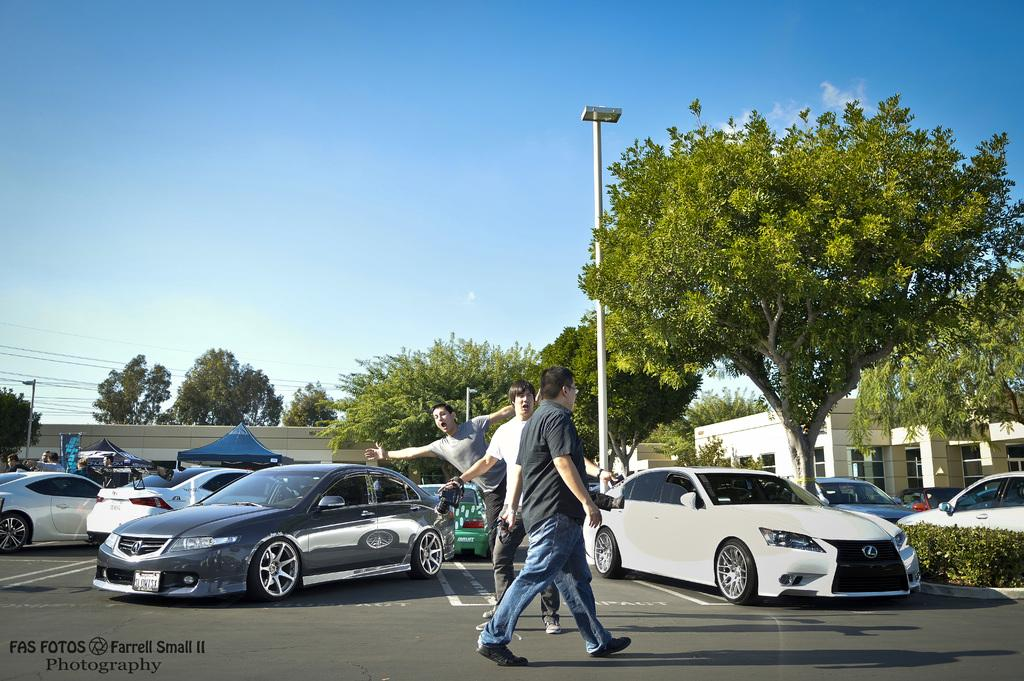What can be seen on the road in the image? There are people on the road in the image. What type of vehicles are visible in the image? There are cars visible in the image. What natural elements can be seen in the image? There are trees in the image. What man-made structures are present in the image? There are buildings in the image. How many sisters are helping each other in the image? There are no sisters present in the image, nor is there any indication of helping or assistance. What type of net is being used to catch fish in the image? There is no net or fishing activity depicted in the image. 